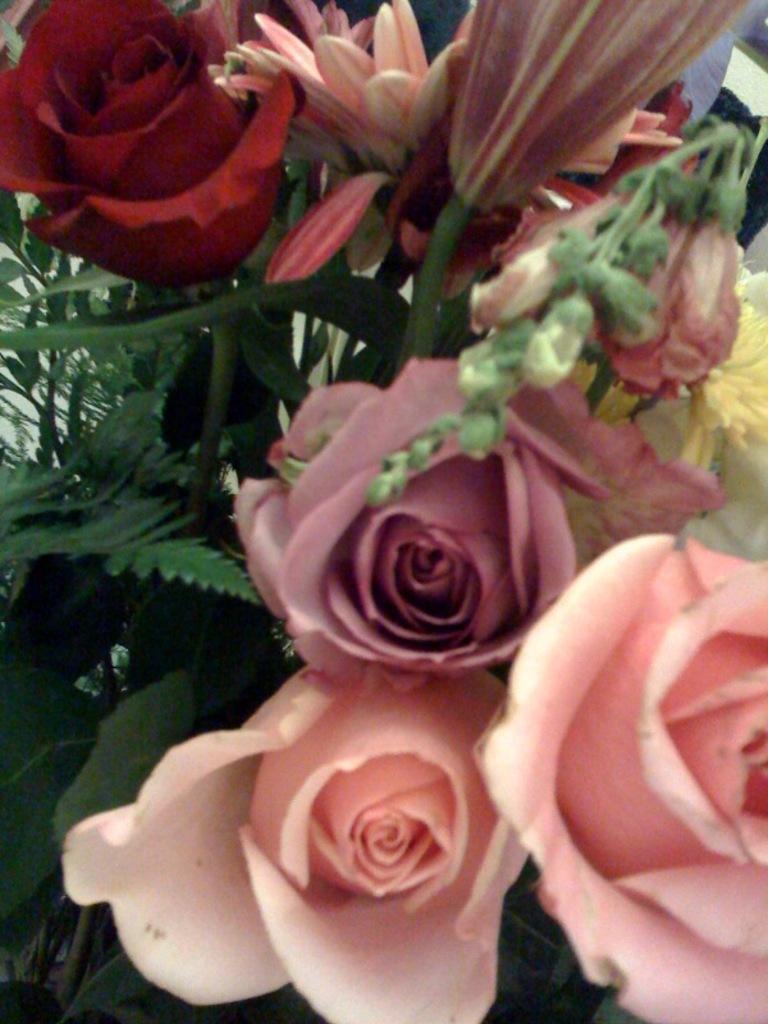Could you give a brief overview of what you see in this image? In the image there is a bouquet with different flowers. 